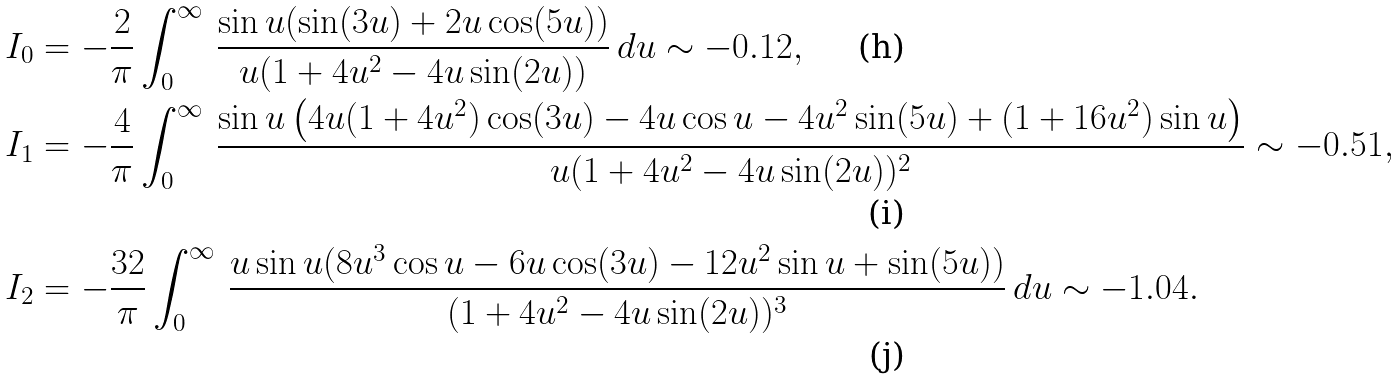Convert formula to latex. <formula><loc_0><loc_0><loc_500><loc_500>I _ { 0 } & = - \frac { 2 } { \pi } \int _ { 0 } ^ { \infty } \, \frac { \sin u ( \sin ( 3 u ) + 2 u \cos ( 5 u ) ) } { u ( 1 + 4 u ^ { 2 } - 4 u \sin ( 2 u ) ) } \, d u \sim - 0 . 1 2 , \\ I _ { 1 } & = - \frac { 4 } { \pi } \int _ { 0 } ^ { \infty } \, \frac { \sin u \left ( 4 u ( 1 + 4 u ^ { 2 } ) \cos ( 3 u ) - 4 u \cos u - 4 u ^ { 2 } \sin ( 5 u ) + ( 1 + 1 6 u ^ { 2 } ) \sin u \right ) } { u ( 1 + 4 u ^ { 2 } - 4 u \sin ( 2 u ) ) ^ { 2 } } \sim - 0 . 5 1 , \\ I _ { 2 } & = - \frac { 3 2 } { \pi } \int _ { 0 } ^ { \infty } \, \frac { u \sin u ( 8 u ^ { 3 } \cos u - 6 u \cos ( 3 u ) - 1 2 u ^ { 2 } \sin u + \sin ( 5 u ) ) } { ( 1 + 4 u ^ { 2 } - 4 u \sin ( 2 u ) ) ^ { 3 } } \, d u \sim - 1 . 0 4 .</formula> 